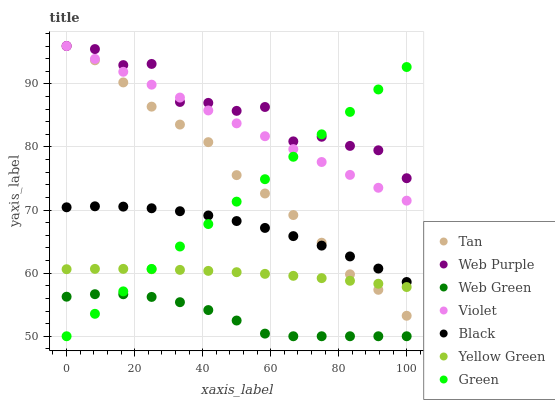Does Web Green have the minimum area under the curve?
Answer yes or no. Yes. Does Web Purple have the maximum area under the curve?
Answer yes or no. Yes. Does Web Purple have the minimum area under the curve?
Answer yes or no. No. Does Web Green have the maximum area under the curve?
Answer yes or no. No. Is Green the smoothest?
Answer yes or no. Yes. Is Web Purple the roughest?
Answer yes or no. Yes. Is Web Green the smoothest?
Answer yes or no. No. Is Web Green the roughest?
Answer yes or no. No. Does Web Green have the lowest value?
Answer yes or no. Yes. Does Web Purple have the lowest value?
Answer yes or no. No. Does Tan have the highest value?
Answer yes or no. Yes. Does Web Green have the highest value?
Answer yes or no. No. Is Web Green less than Web Purple?
Answer yes or no. Yes. Is Web Purple greater than Yellow Green?
Answer yes or no. Yes. Does Tan intersect Green?
Answer yes or no. Yes. Is Tan less than Green?
Answer yes or no. No. Is Tan greater than Green?
Answer yes or no. No. Does Web Green intersect Web Purple?
Answer yes or no. No. 